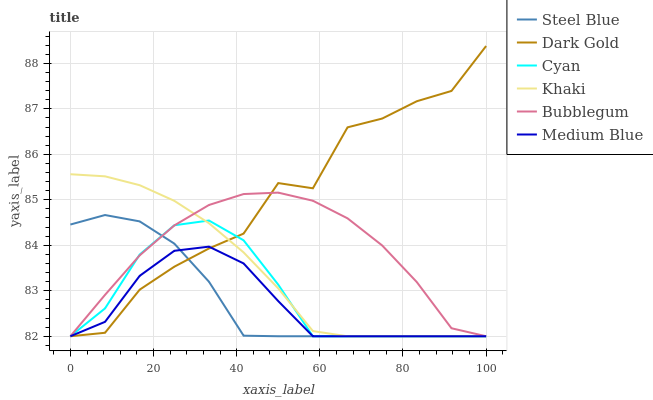Does Dark Gold have the minimum area under the curve?
Answer yes or no. No. Does Medium Blue have the maximum area under the curve?
Answer yes or no. No. Is Medium Blue the smoothest?
Answer yes or no. No. Is Medium Blue the roughest?
Answer yes or no. No. Does Medium Blue have the highest value?
Answer yes or no. No. 